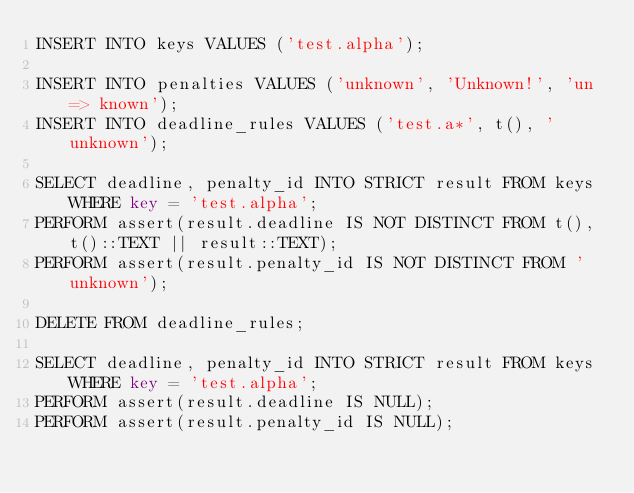<code> <loc_0><loc_0><loc_500><loc_500><_SQL_>INSERT INTO keys VALUES ('test.alpha');

INSERT INTO penalties VALUES ('unknown', 'Unknown!', 'un => known');
INSERT INTO deadline_rules VALUES ('test.a*', t(), 'unknown');

SELECT deadline, penalty_id INTO STRICT result FROM keys WHERE key = 'test.alpha';
PERFORM assert(result.deadline IS NOT DISTINCT FROM t(), t()::TEXT || result::TEXT);
PERFORM assert(result.penalty_id IS NOT DISTINCT FROM 'unknown');

DELETE FROM deadline_rules;

SELECT deadline, penalty_id INTO STRICT result FROM keys WHERE key = 'test.alpha';
PERFORM assert(result.deadline IS NULL);
PERFORM assert(result.penalty_id IS NULL);
</code> 